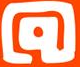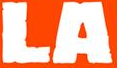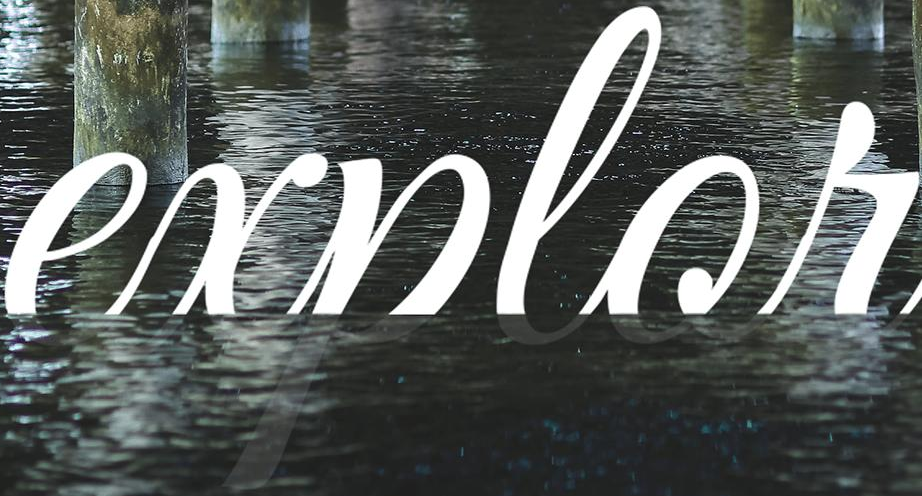What words are shown in these images in order, separated by a semicolon? @; LA; explor 